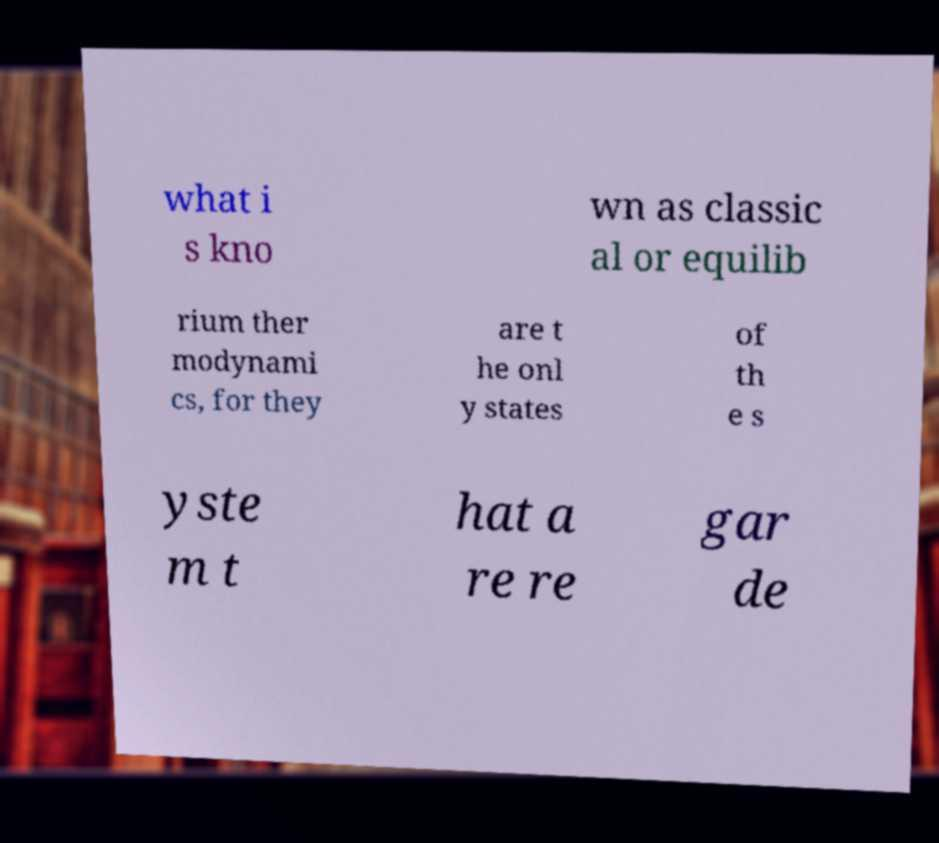Could you assist in decoding the text presented in this image and type it out clearly? what i s kno wn as classic al or equilib rium ther modynami cs, for they are t he onl y states of th e s yste m t hat a re re gar de 